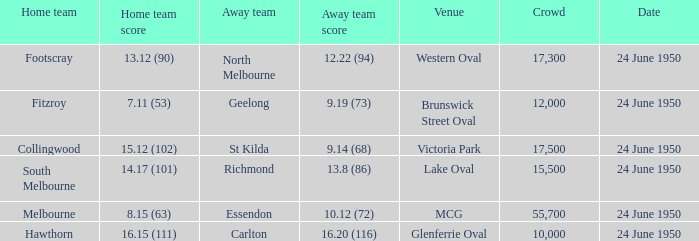Who was the home team for the game where North Melbourne was the away team? Footscray. 